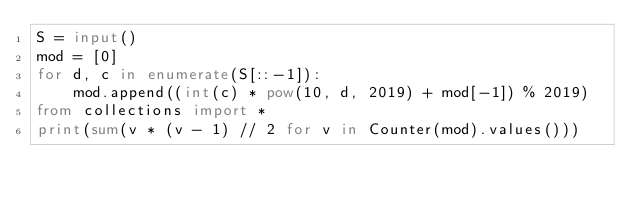<code> <loc_0><loc_0><loc_500><loc_500><_Python_>S = input()
mod = [0]
for d, c in enumerate(S[::-1]):
    mod.append((int(c) * pow(10, d, 2019) + mod[-1]) % 2019)
from collections import *
print(sum(v * (v - 1) // 2 for v in Counter(mod).values()))
</code> 